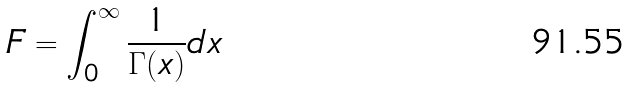<formula> <loc_0><loc_0><loc_500><loc_500>F = \int _ { 0 } ^ { \infty } \frac { 1 } { \Gamma ( x ) } d x</formula> 